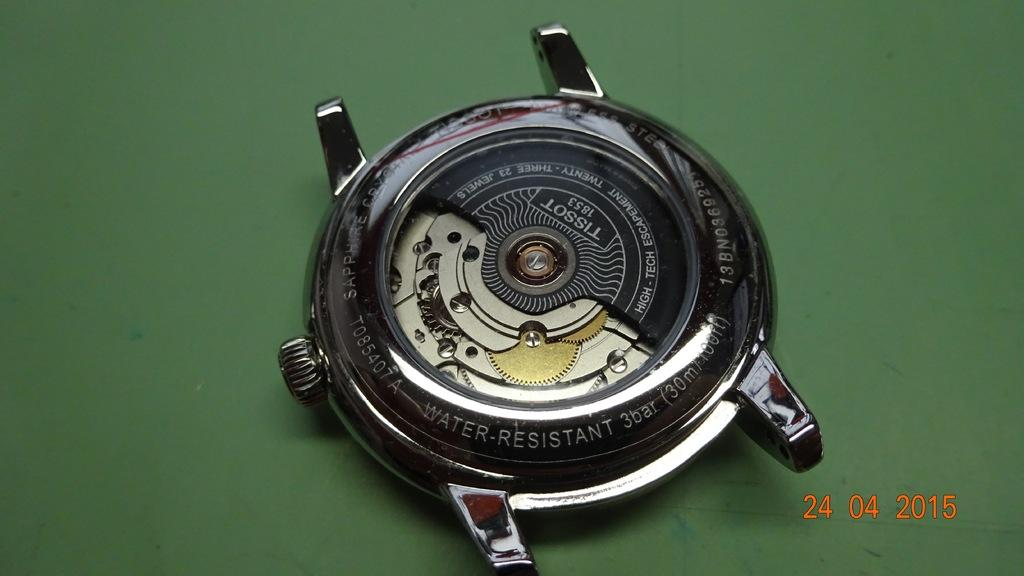Provide a one-sentence caption for the provided image. The back of a Tissot wrist watch is laying open, on a green surface, in a photo taken on April 24, 2015. 